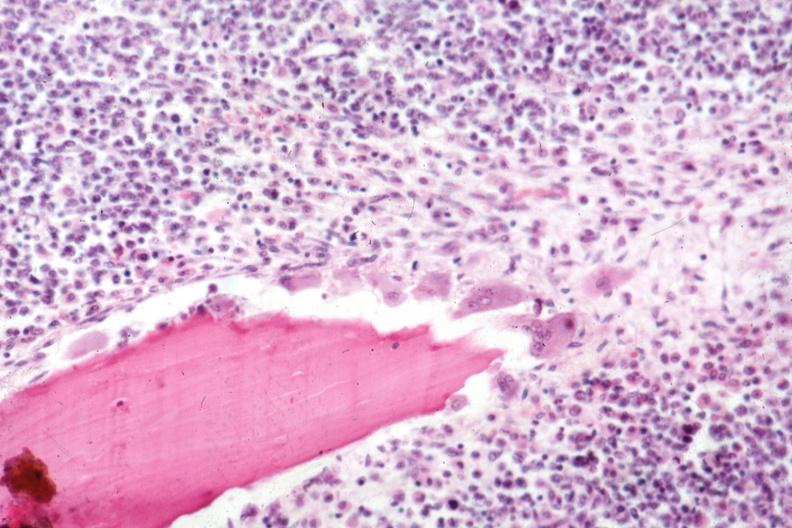s joints present?
Answer the question using a single word or phrase. Yes 